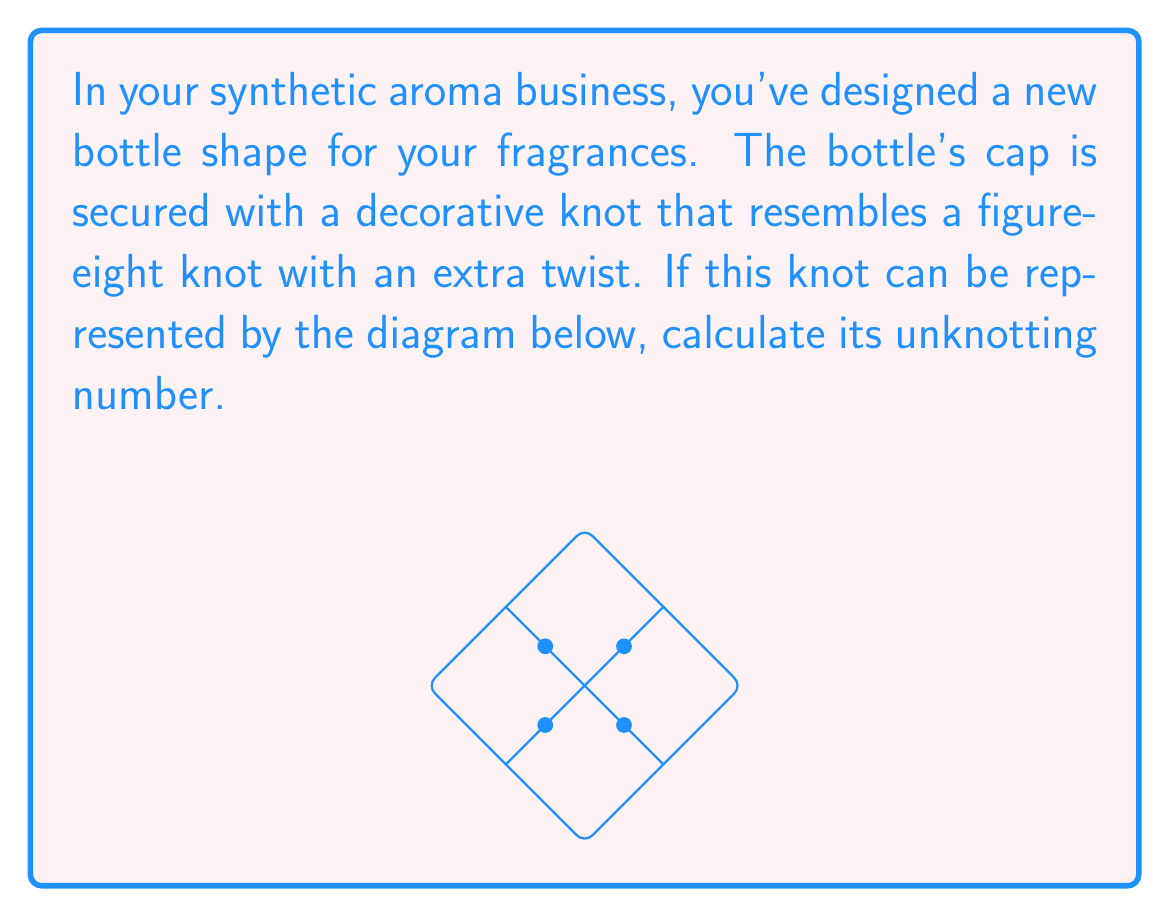What is the answer to this math problem? To calculate the unknotting number of this knot, we need to follow these steps:

1) First, we need to identify the knot. The diagram shows a figure-eight knot with an additional crossing, which is known as the $5_2$ knot in the Alexander-Briggs notation.

2) The unknotting number of a knot is the minimum number of times the knot must be passed through itself to untangle it into the unknot (trivial knot).

3) For the $5_2$ knot:
   
   a) It's known that its unknotting number is 2.
   
   b) This can be verified by performing two crossing changes:
      - Change one of the crossings in the figure-eight part
      - Change the additional crossing

4) Mathematically, we can express this as:

   $$u(5_2) = 2$$

   Where $u(K)$ denotes the unknotting number of knot $K$.

5) It's worth noting that the unknotting number is always less than or equal to the floor of half the crossing number. In this case:

   $$u(5_2) \leq \lfloor \frac{5}{2} \rfloor = 2$$

   Which confirms our result.

Therefore, the unknotting number of the knot used in your fragrance bottle design is 2.
Answer: 2 